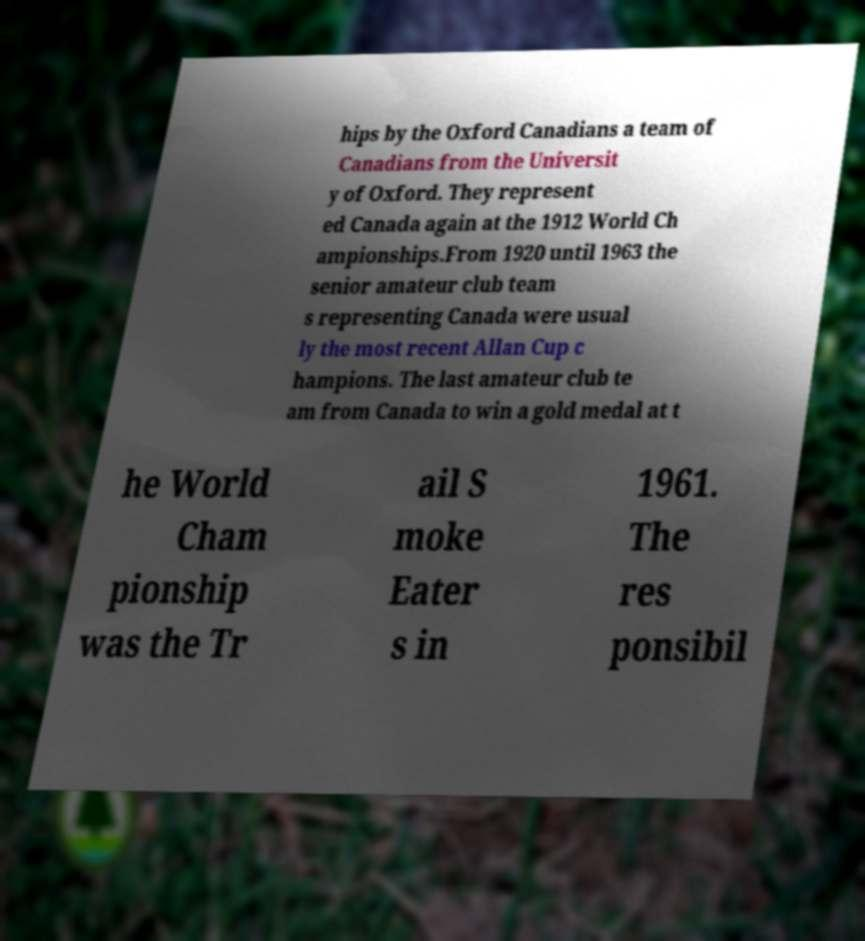Please identify and transcribe the text found in this image. hips by the Oxford Canadians a team of Canadians from the Universit y of Oxford. They represent ed Canada again at the 1912 World Ch ampionships.From 1920 until 1963 the senior amateur club team s representing Canada were usual ly the most recent Allan Cup c hampions. The last amateur club te am from Canada to win a gold medal at t he World Cham pionship was the Tr ail S moke Eater s in 1961. The res ponsibil 